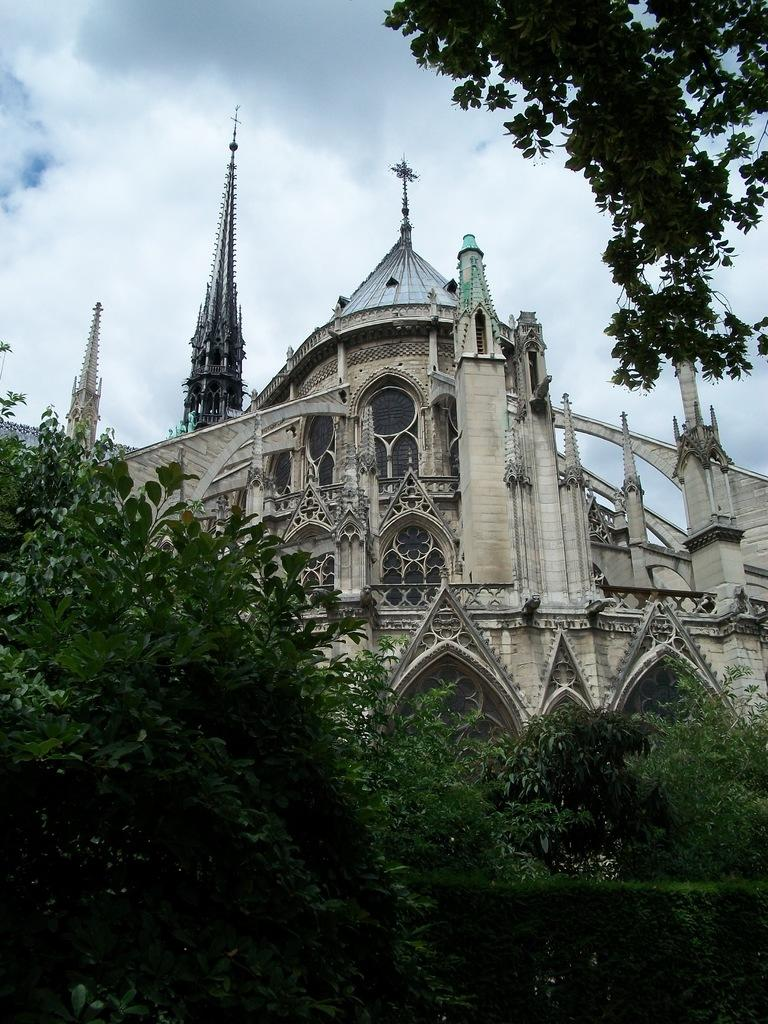What type of structure is visible in the image? There is a building in the image. What other natural elements can be seen in the image? There are trees in the image. What is visible in the background of the image? The sky is visible in the background of the image. What can be observed in the sky? Clouds are present in the sky. How many cords are hanging from the trees in the image? There are no cords hanging from the trees in the image. What type of bird can be seen perched on the building in the image? There are no birds visible in the image, including wrens. 